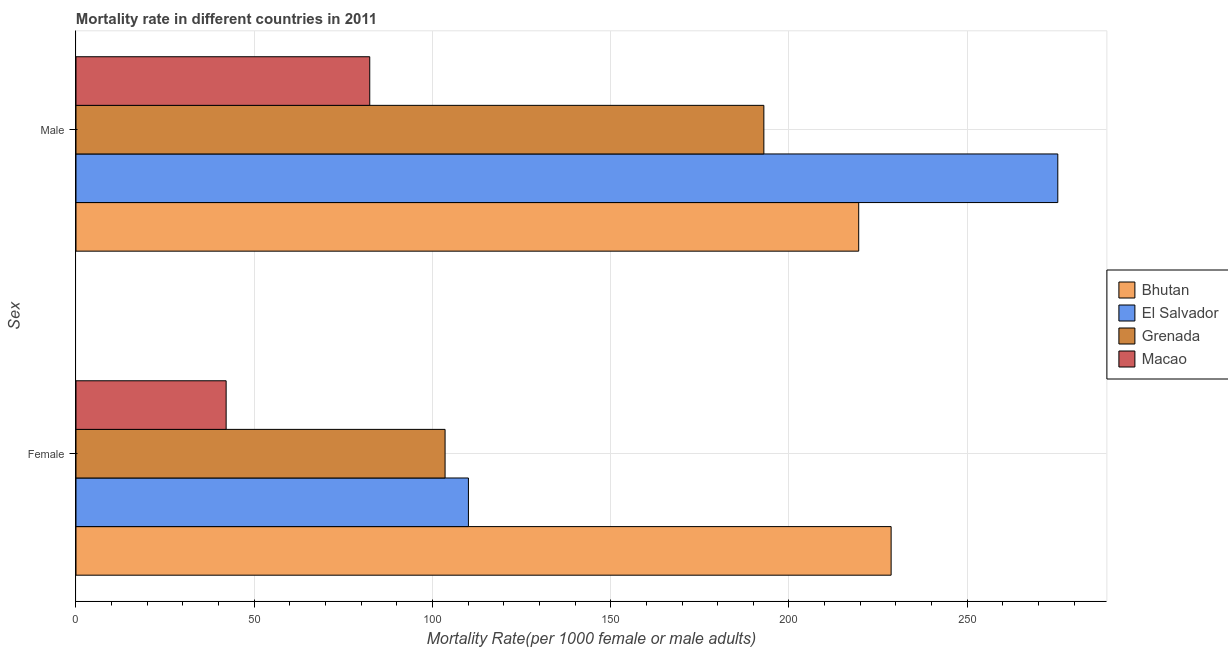How many different coloured bars are there?
Your response must be concise. 4. How many groups of bars are there?
Your answer should be compact. 2. How many bars are there on the 2nd tick from the top?
Provide a succinct answer. 4. How many bars are there on the 1st tick from the bottom?
Your answer should be compact. 4. What is the female mortality rate in Grenada?
Provide a succinct answer. 103.54. Across all countries, what is the maximum female mortality rate?
Offer a very short reply. 228.66. Across all countries, what is the minimum male mortality rate?
Your answer should be very brief. 82.41. In which country was the female mortality rate maximum?
Your answer should be compact. Bhutan. In which country was the female mortality rate minimum?
Ensure brevity in your answer.  Macao. What is the total female mortality rate in the graph?
Ensure brevity in your answer.  484.41. What is the difference between the male mortality rate in Macao and that in El Salvador?
Your answer should be compact. -193.01. What is the difference between the female mortality rate in Macao and the male mortality rate in El Salvador?
Provide a succinct answer. -233.3. What is the average male mortality rate per country?
Make the answer very short. 192.59. What is the difference between the male mortality rate and female mortality rate in Bhutan?
Provide a short and direct response. -9.09. In how many countries, is the male mortality rate greater than 100 ?
Provide a short and direct response. 3. What is the ratio of the female mortality rate in El Salvador to that in Macao?
Make the answer very short. 2.61. What does the 1st bar from the top in Female represents?
Give a very brief answer. Macao. What does the 4th bar from the bottom in Male represents?
Keep it short and to the point. Macao. How many bars are there?
Ensure brevity in your answer.  8. How many countries are there in the graph?
Ensure brevity in your answer.  4. Does the graph contain any zero values?
Give a very brief answer. No. What is the title of the graph?
Your answer should be very brief. Mortality rate in different countries in 2011. Does "Virgin Islands" appear as one of the legend labels in the graph?
Offer a terse response. No. What is the label or title of the X-axis?
Your answer should be very brief. Mortality Rate(per 1000 female or male adults). What is the label or title of the Y-axis?
Ensure brevity in your answer.  Sex. What is the Mortality Rate(per 1000 female or male adults) in Bhutan in Female?
Provide a succinct answer. 228.66. What is the Mortality Rate(per 1000 female or male adults) in El Salvador in Female?
Provide a succinct answer. 110.09. What is the Mortality Rate(per 1000 female or male adults) of Grenada in Female?
Provide a short and direct response. 103.54. What is the Mortality Rate(per 1000 female or male adults) of Macao in Female?
Your response must be concise. 42.12. What is the Mortality Rate(per 1000 female or male adults) of Bhutan in Male?
Ensure brevity in your answer.  219.57. What is the Mortality Rate(per 1000 female or male adults) of El Salvador in Male?
Offer a very short reply. 275.42. What is the Mortality Rate(per 1000 female or male adults) of Grenada in Male?
Provide a succinct answer. 192.97. What is the Mortality Rate(per 1000 female or male adults) in Macao in Male?
Your answer should be very brief. 82.41. Across all Sex, what is the maximum Mortality Rate(per 1000 female or male adults) in Bhutan?
Provide a short and direct response. 228.66. Across all Sex, what is the maximum Mortality Rate(per 1000 female or male adults) of El Salvador?
Give a very brief answer. 275.42. Across all Sex, what is the maximum Mortality Rate(per 1000 female or male adults) of Grenada?
Make the answer very short. 192.97. Across all Sex, what is the maximum Mortality Rate(per 1000 female or male adults) of Macao?
Your answer should be compact. 82.41. Across all Sex, what is the minimum Mortality Rate(per 1000 female or male adults) in Bhutan?
Provide a short and direct response. 219.57. Across all Sex, what is the minimum Mortality Rate(per 1000 female or male adults) in El Salvador?
Provide a short and direct response. 110.09. Across all Sex, what is the minimum Mortality Rate(per 1000 female or male adults) of Grenada?
Make the answer very short. 103.54. Across all Sex, what is the minimum Mortality Rate(per 1000 female or male adults) of Macao?
Make the answer very short. 42.12. What is the total Mortality Rate(per 1000 female or male adults) of Bhutan in the graph?
Provide a short and direct response. 448.24. What is the total Mortality Rate(per 1000 female or male adults) of El Salvador in the graph?
Your answer should be compact. 385.51. What is the total Mortality Rate(per 1000 female or male adults) of Grenada in the graph?
Your answer should be very brief. 296.5. What is the total Mortality Rate(per 1000 female or male adults) in Macao in the graph?
Ensure brevity in your answer.  124.53. What is the difference between the Mortality Rate(per 1000 female or male adults) in Bhutan in Female and that in Male?
Give a very brief answer. 9.09. What is the difference between the Mortality Rate(per 1000 female or male adults) in El Salvador in Female and that in Male?
Keep it short and to the point. -165.33. What is the difference between the Mortality Rate(per 1000 female or male adults) in Grenada in Female and that in Male?
Make the answer very short. -89.43. What is the difference between the Mortality Rate(per 1000 female or male adults) in Macao in Female and that in Male?
Your answer should be compact. -40.29. What is the difference between the Mortality Rate(per 1000 female or male adults) of Bhutan in Female and the Mortality Rate(per 1000 female or male adults) of El Salvador in Male?
Offer a terse response. -46.76. What is the difference between the Mortality Rate(per 1000 female or male adults) in Bhutan in Female and the Mortality Rate(per 1000 female or male adults) in Grenada in Male?
Provide a succinct answer. 35.7. What is the difference between the Mortality Rate(per 1000 female or male adults) of Bhutan in Female and the Mortality Rate(per 1000 female or male adults) of Macao in Male?
Offer a very short reply. 146.26. What is the difference between the Mortality Rate(per 1000 female or male adults) of El Salvador in Female and the Mortality Rate(per 1000 female or male adults) of Grenada in Male?
Give a very brief answer. -82.88. What is the difference between the Mortality Rate(per 1000 female or male adults) in El Salvador in Female and the Mortality Rate(per 1000 female or male adults) in Macao in Male?
Your answer should be very brief. 27.68. What is the difference between the Mortality Rate(per 1000 female or male adults) of Grenada in Female and the Mortality Rate(per 1000 female or male adults) of Macao in Male?
Offer a terse response. 21.13. What is the average Mortality Rate(per 1000 female or male adults) in Bhutan per Sex?
Ensure brevity in your answer.  224.12. What is the average Mortality Rate(per 1000 female or male adults) of El Salvador per Sex?
Ensure brevity in your answer.  192.75. What is the average Mortality Rate(per 1000 female or male adults) in Grenada per Sex?
Offer a terse response. 148.25. What is the average Mortality Rate(per 1000 female or male adults) of Macao per Sex?
Keep it short and to the point. 62.26. What is the difference between the Mortality Rate(per 1000 female or male adults) in Bhutan and Mortality Rate(per 1000 female or male adults) in El Salvador in Female?
Keep it short and to the point. 118.58. What is the difference between the Mortality Rate(per 1000 female or male adults) of Bhutan and Mortality Rate(per 1000 female or male adults) of Grenada in Female?
Keep it short and to the point. 125.13. What is the difference between the Mortality Rate(per 1000 female or male adults) of Bhutan and Mortality Rate(per 1000 female or male adults) of Macao in Female?
Ensure brevity in your answer.  186.54. What is the difference between the Mortality Rate(per 1000 female or male adults) in El Salvador and Mortality Rate(per 1000 female or male adults) in Grenada in Female?
Make the answer very short. 6.55. What is the difference between the Mortality Rate(per 1000 female or male adults) of El Salvador and Mortality Rate(per 1000 female or male adults) of Macao in Female?
Offer a very short reply. 67.97. What is the difference between the Mortality Rate(per 1000 female or male adults) of Grenada and Mortality Rate(per 1000 female or male adults) of Macao in Female?
Your answer should be very brief. 61.42. What is the difference between the Mortality Rate(per 1000 female or male adults) of Bhutan and Mortality Rate(per 1000 female or male adults) of El Salvador in Male?
Give a very brief answer. -55.85. What is the difference between the Mortality Rate(per 1000 female or male adults) of Bhutan and Mortality Rate(per 1000 female or male adults) of Grenada in Male?
Give a very brief answer. 26.61. What is the difference between the Mortality Rate(per 1000 female or male adults) in Bhutan and Mortality Rate(per 1000 female or male adults) in Macao in Male?
Provide a succinct answer. 137.16. What is the difference between the Mortality Rate(per 1000 female or male adults) of El Salvador and Mortality Rate(per 1000 female or male adults) of Grenada in Male?
Your response must be concise. 82.45. What is the difference between the Mortality Rate(per 1000 female or male adults) of El Salvador and Mortality Rate(per 1000 female or male adults) of Macao in Male?
Provide a short and direct response. 193.01. What is the difference between the Mortality Rate(per 1000 female or male adults) in Grenada and Mortality Rate(per 1000 female or male adults) in Macao in Male?
Provide a short and direct response. 110.56. What is the ratio of the Mortality Rate(per 1000 female or male adults) of Bhutan in Female to that in Male?
Your response must be concise. 1.04. What is the ratio of the Mortality Rate(per 1000 female or male adults) of El Salvador in Female to that in Male?
Offer a terse response. 0.4. What is the ratio of the Mortality Rate(per 1000 female or male adults) in Grenada in Female to that in Male?
Your response must be concise. 0.54. What is the ratio of the Mortality Rate(per 1000 female or male adults) of Macao in Female to that in Male?
Your answer should be very brief. 0.51. What is the difference between the highest and the second highest Mortality Rate(per 1000 female or male adults) in Bhutan?
Provide a succinct answer. 9.09. What is the difference between the highest and the second highest Mortality Rate(per 1000 female or male adults) in El Salvador?
Offer a terse response. 165.33. What is the difference between the highest and the second highest Mortality Rate(per 1000 female or male adults) of Grenada?
Your answer should be very brief. 89.43. What is the difference between the highest and the second highest Mortality Rate(per 1000 female or male adults) in Macao?
Keep it short and to the point. 40.29. What is the difference between the highest and the lowest Mortality Rate(per 1000 female or male adults) of Bhutan?
Provide a succinct answer. 9.09. What is the difference between the highest and the lowest Mortality Rate(per 1000 female or male adults) of El Salvador?
Keep it short and to the point. 165.33. What is the difference between the highest and the lowest Mortality Rate(per 1000 female or male adults) of Grenada?
Make the answer very short. 89.43. What is the difference between the highest and the lowest Mortality Rate(per 1000 female or male adults) of Macao?
Provide a short and direct response. 40.29. 